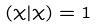<formula> <loc_0><loc_0><loc_500><loc_500>( \chi | \chi ) = 1</formula> 